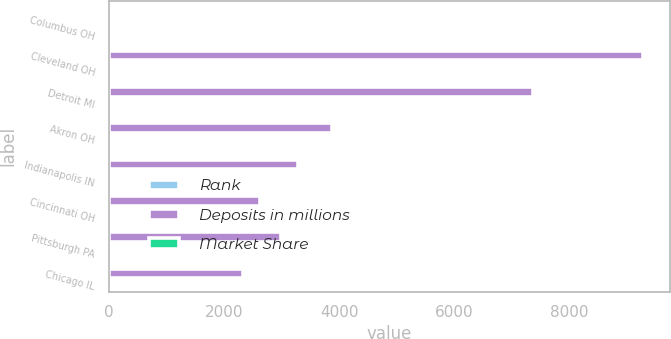Convert chart to OTSL. <chart><loc_0><loc_0><loc_500><loc_500><stacked_bar_chart><ecel><fcel>Columbus OH<fcel>Cleveland OH<fcel>Detroit MI<fcel>Akron OH<fcel>Indianapolis IN<fcel>Cincinnati OH<fcel>Pittsburgh PA<fcel>Chicago IL<nl><fcel>Rank<fcel>1<fcel>2<fcel>5<fcel>1<fcel>4<fcel>4<fcel>9<fcel>19<nl><fcel>Deposits in millions<fcel>9<fcel>9273<fcel>7358<fcel>3864<fcel>3285<fcel>2623<fcel>2978<fcel>2324<nl><fcel>Market Share<fcel>34<fcel>14<fcel>6<fcel>29<fcel>7<fcel>2<fcel>2<fcel>1<nl></chart> 